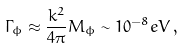<formula> <loc_0><loc_0><loc_500><loc_500>\Gamma _ { \phi } \approx \frac { k ^ { 2 } } { 4 \pi } M _ { \phi } \sim 1 0 ^ { - 8 } e V \, ,</formula> 